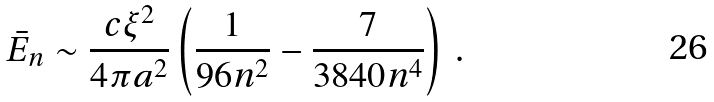Convert formula to latex. <formula><loc_0><loc_0><loc_500><loc_500>\bar { E } _ { n } \sim \frac { c \xi ^ { 2 } } { 4 \pi a ^ { 2 } } \left ( \frac { 1 } { 9 6 n ^ { 2 } } - \frac { 7 } { 3 8 4 0 n ^ { 4 } } \right ) \, { . }</formula> 